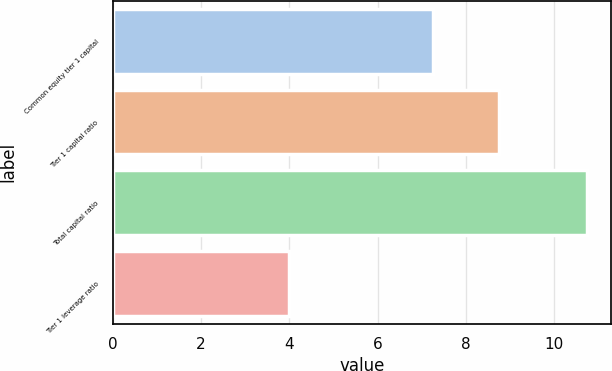Convert chart. <chart><loc_0><loc_0><loc_500><loc_500><bar_chart><fcel>Common equity tier 1 capital<fcel>Tier 1 capital ratio<fcel>Total capital ratio<fcel>Tier 1 leverage ratio<nl><fcel>7.25<fcel>8.75<fcel>10.75<fcel>4<nl></chart> 